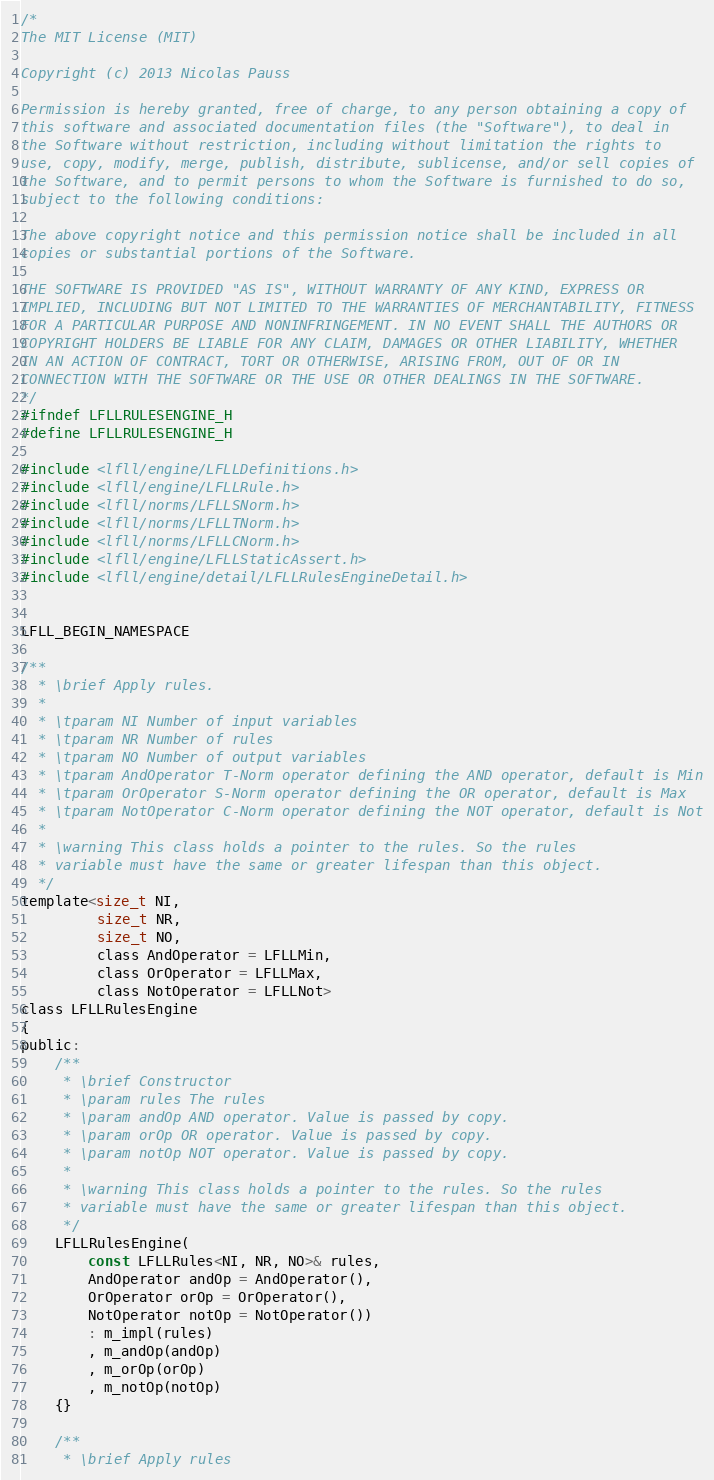Convert code to text. <code><loc_0><loc_0><loc_500><loc_500><_C_>/*
The MIT License (MIT)

Copyright (c) 2013 Nicolas Pauss

Permission is hereby granted, free of charge, to any person obtaining a copy of
this software and associated documentation files (the "Software"), to deal in
the Software without restriction, including without limitation the rights to
use, copy, modify, merge, publish, distribute, sublicense, and/or sell copies of
the Software, and to permit persons to whom the Software is furnished to do so,
subject to the following conditions:

The above copyright notice and this permission notice shall be included in all
copies or substantial portions of the Software.

THE SOFTWARE IS PROVIDED "AS IS", WITHOUT WARRANTY OF ANY KIND, EXPRESS OR
IMPLIED, INCLUDING BUT NOT LIMITED TO THE WARRANTIES OF MERCHANTABILITY, FITNESS
FOR A PARTICULAR PURPOSE AND NONINFRINGEMENT. IN NO EVENT SHALL THE AUTHORS OR
COPYRIGHT HOLDERS BE LIABLE FOR ANY CLAIM, DAMAGES OR OTHER LIABILITY, WHETHER
IN AN ACTION OF CONTRACT, TORT OR OTHERWISE, ARISING FROM, OUT OF OR IN
CONNECTION WITH THE SOFTWARE OR THE USE OR OTHER DEALINGS IN THE SOFTWARE.
*/
#ifndef LFLLRULESENGINE_H
#define LFLLRULESENGINE_H

#include <lfll/engine/LFLLDefinitions.h>
#include <lfll/engine/LFLLRule.h>
#include <lfll/norms/LFLLSNorm.h>
#include <lfll/norms/LFLLTNorm.h>
#include <lfll/norms/LFLLCNorm.h>
#include <lfll/engine/LFLLStaticAssert.h>
#include <lfll/engine/detail/LFLLRulesEngineDetail.h>


LFLL_BEGIN_NAMESPACE

/**
  * \brief Apply rules.
  *
  * \tparam NI Number of input variables
  * \tparam NR Number of rules
  * \tparam NO Number of output variables
  * \tparam AndOperator T-Norm operator defining the AND operator, default is Min
  * \tparam OrOperator S-Norm operator defining the OR operator, default is Max
  * \tparam NotOperator C-Norm operator defining the NOT operator, default is Not
  *
  * \warning This class holds a pointer to the rules. So the rules 
  * variable must have the same or greater lifespan than this object.
  */
template<size_t NI,
         size_t NR,
         size_t NO,
         class AndOperator = LFLLMin,
         class OrOperator = LFLLMax,
         class NotOperator = LFLLNot>
class LFLLRulesEngine
{
public:
	/**
	 * \brief Constructor
	 * \param rules The rules
	 * \param andOp AND operator. Value is passed by copy.
	 * \param orOp OR operator. Value is passed by copy.
	 * \param notOp NOT operator. Value is passed by copy.
	 * 
 	 * \warning This class holds a pointer to the rules. So the rules 
     * variable must have the same or greater lifespan than this object.
	 */
    LFLLRulesEngine(
        const LFLLRules<NI, NR, NO>& rules,
        AndOperator andOp = AndOperator(),
        OrOperator orOp = OrOperator(),
        NotOperator notOp = NotOperator())
        : m_impl(rules)
        , m_andOp(andOp)
        , m_orOp(orOp)
        , m_notOp(notOp)
    {}

	/**
	 * \brief Apply rules</code> 